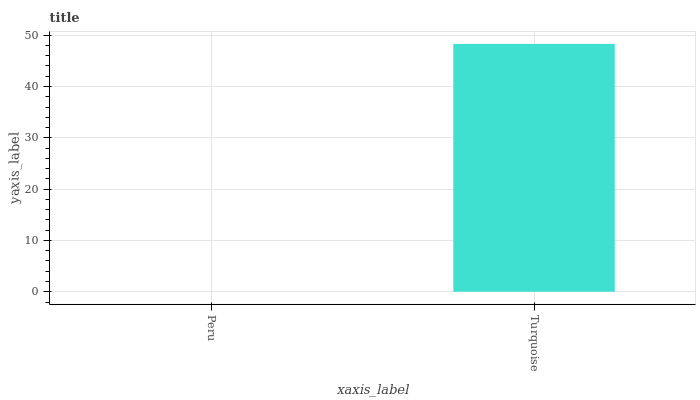Is Peru the minimum?
Answer yes or no. Yes. Is Turquoise the maximum?
Answer yes or no. Yes. Is Turquoise the minimum?
Answer yes or no. No. Is Turquoise greater than Peru?
Answer yes or no. Yes. Is Peru less than Turquoise?
Answer yes or no. Yes. Is Peru greater than Turquoise?
Answer yes or no. No. Is Turquoise less than Peru?
Answer yes or no. No. Is Turquoise the high median?
Answer yes or no. Yes. Is Peru the low median?
Answer yes or no. Yes. Is Peru the high median?
Answer yes or no. No. Is Turquoise the low median?
Answer yes or no. No. 